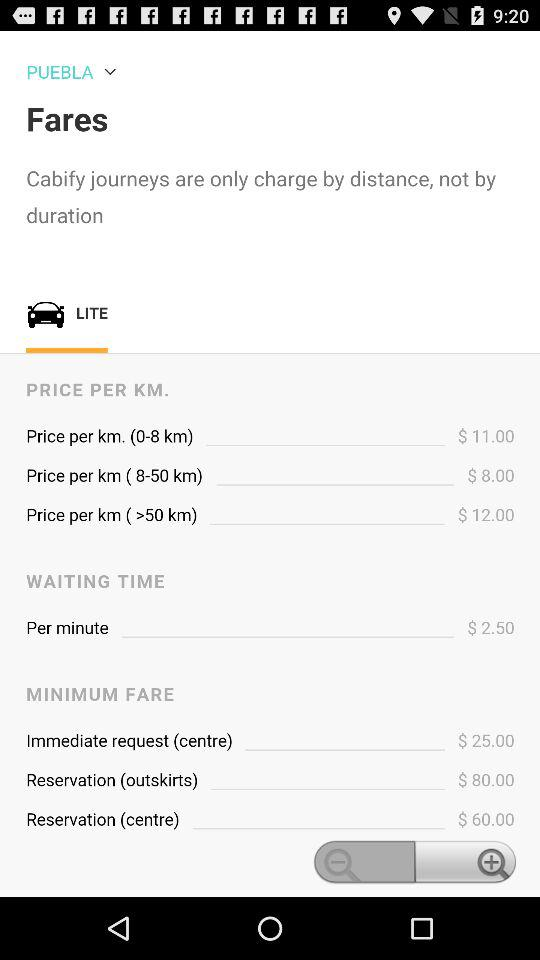What is the price per km after 50 km? The price per km after 50 km is $12.00. 